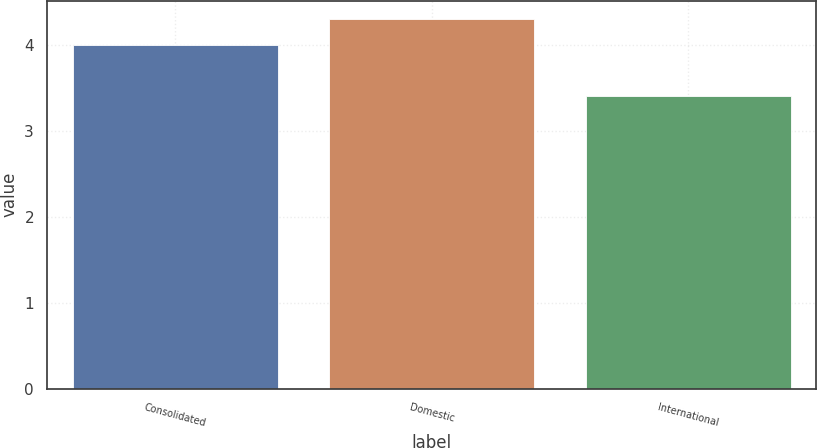<chart> <loc_0><loc_0><loc_500><loc_500><bar_chart><fcel>Consolidated<fcel>Domestic<fcel>International<nl><fcel>4<fcel>4.3<fcel>3.4<nl></chart> 